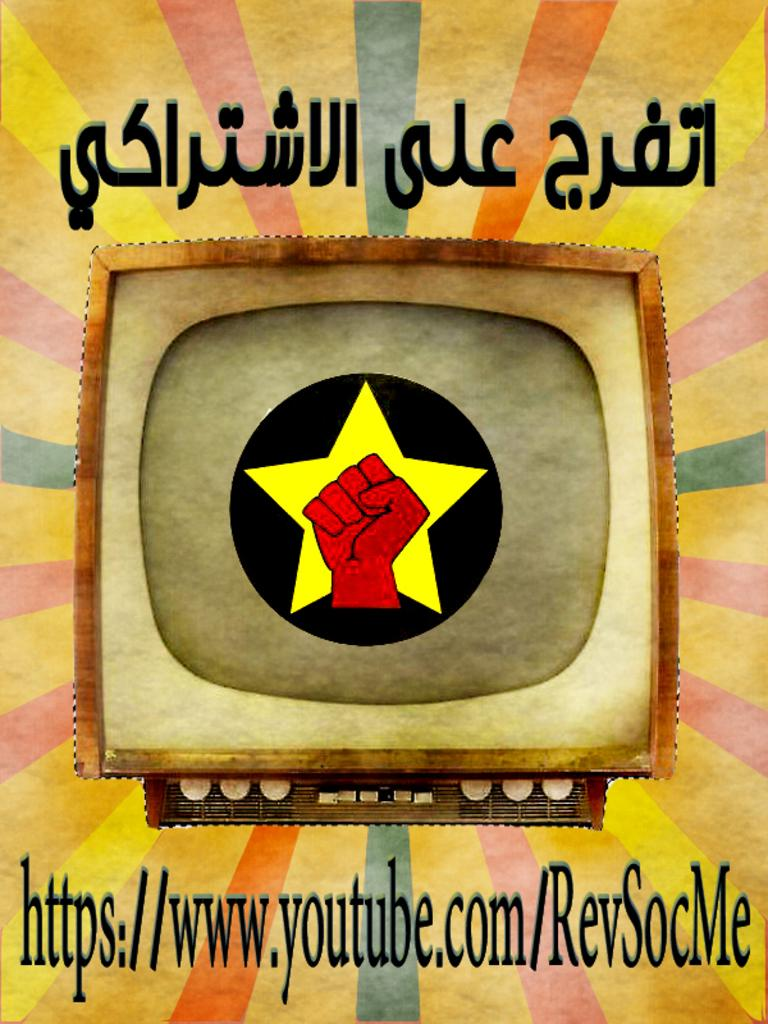<image>
Render a clear and concise summary of the photo. An ad for RevSocMe on Youtube shows a red fist against a yellow star. 